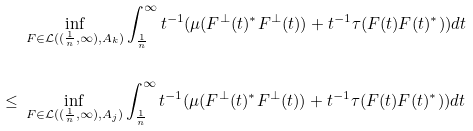Convert formula to latex. <formula><loc_0><loc_0><loc_500><loc_500>& \ \inf _ { F \in \mathcal { L } ( ( \frac { 1 } { n } , \infty ) , A _ { k } ) } \int _ { \frac { 1 } { n } } ^ { \infty } t ^ { - 1 } ( \mu ( F ^ { \perp } ( t ) ^ { * } F ^ { \perp } ( t ) ) + t ^ { - 1 } \tau ( F ( t ) F ( t ) ^ { * } ) ) d t \\ \\ \leq & \ \inf _ { F \in \mathcal { L } ( ( \frac { 1 } { n } , \infty ) , A _ { j } ) } \int _ { \frac { 1 } { n } } ^ { \infty } t ^ { - 1 } ( \mu ( F ^ { \perp } ( t ) ^ { * } F ^ { \perp } ( t ) ) + t ^ { - 1 } \tau ( F ( t ) F ( t ) ^ { * } ) ) d t</formula> 